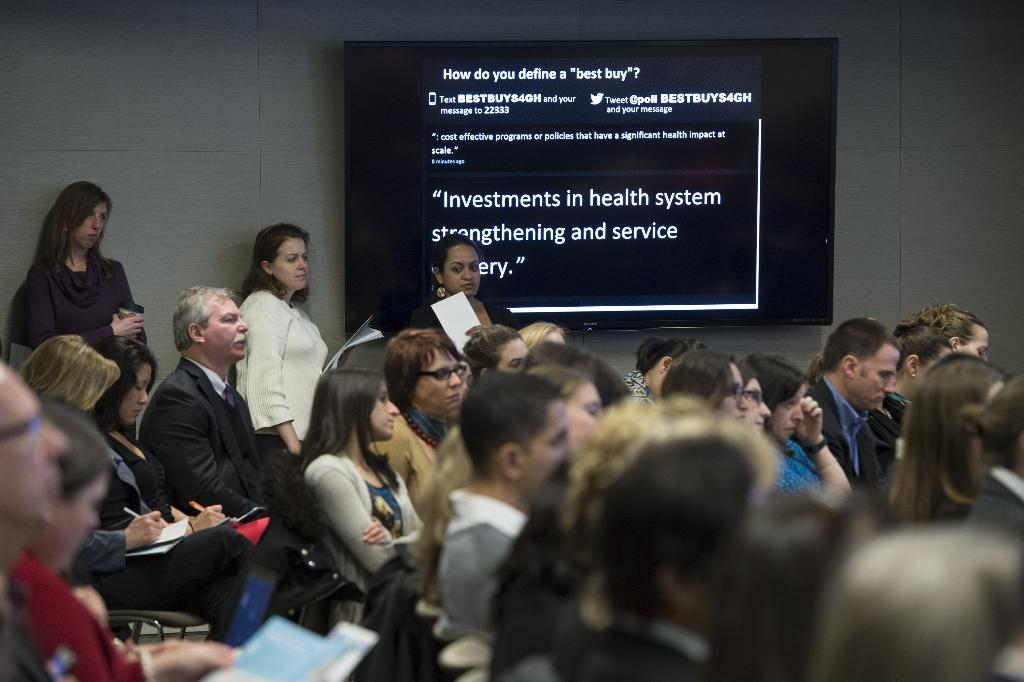What is the general activity of the people in the room? The people in the room are seated, and some are holding pens and papers. How many people are standing at the back? Three people are standing at the back. What is on the wall in the room? There is a screen on a wall. What type of rice is being served at the brothers' home in the image? There is no reference to brothers or a home in the image, nor is there any indication of food being served. 